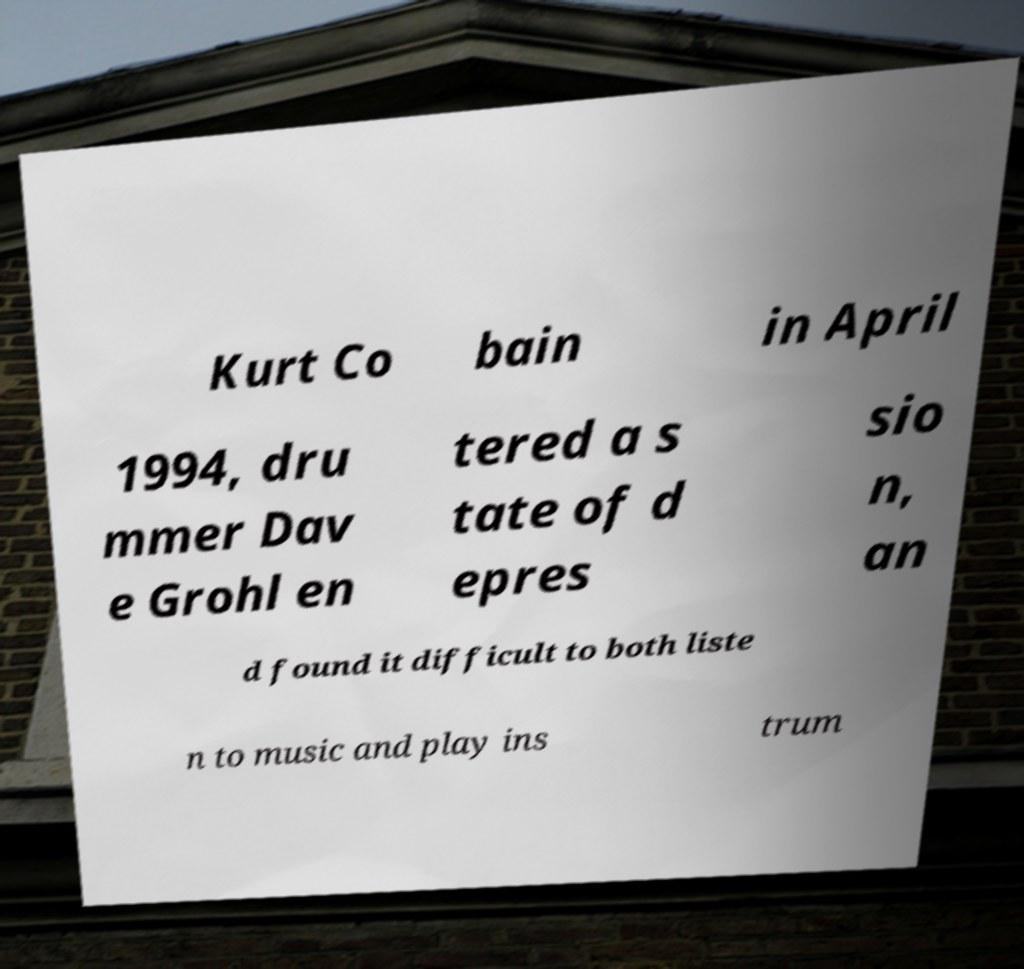Please identify and transcribe the text found in this image. Kurt Co bain in April 1994, dru mmer Dav e Grohl en tered a s tate of d epres sio n, an d found it difficult to both liste n to music and play ins trum 